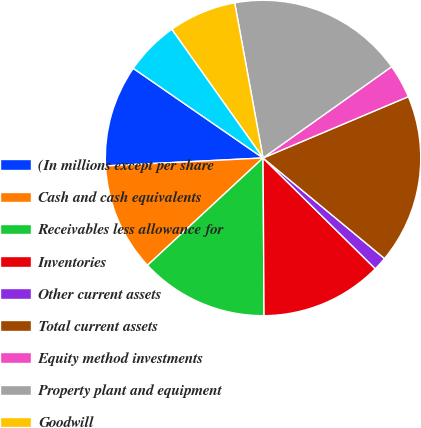<chart> <loc_0><loc_0><loc_500><loc_500><pie_chart><fcel>(In millions except per share<fcel>Cash and cash equivalents<fcel>Receivables less allowance for<fcel>Inventories<fcel>Other current assets<fcel>Total current assets<fcel>Equity method investments<fcel>Property plant and equipment<fcel>Goodwill<fcel>Other noncurrent assets<nl><fcel>10.42%<fcel>11.11%<fcel>13.19%<fcel>12.5%<fcel>1.39%<fcel>17.36%<fcel>3.47%<fcel>18.05%<fcel>6.94%<fcel>5.56%<nl></chart> 